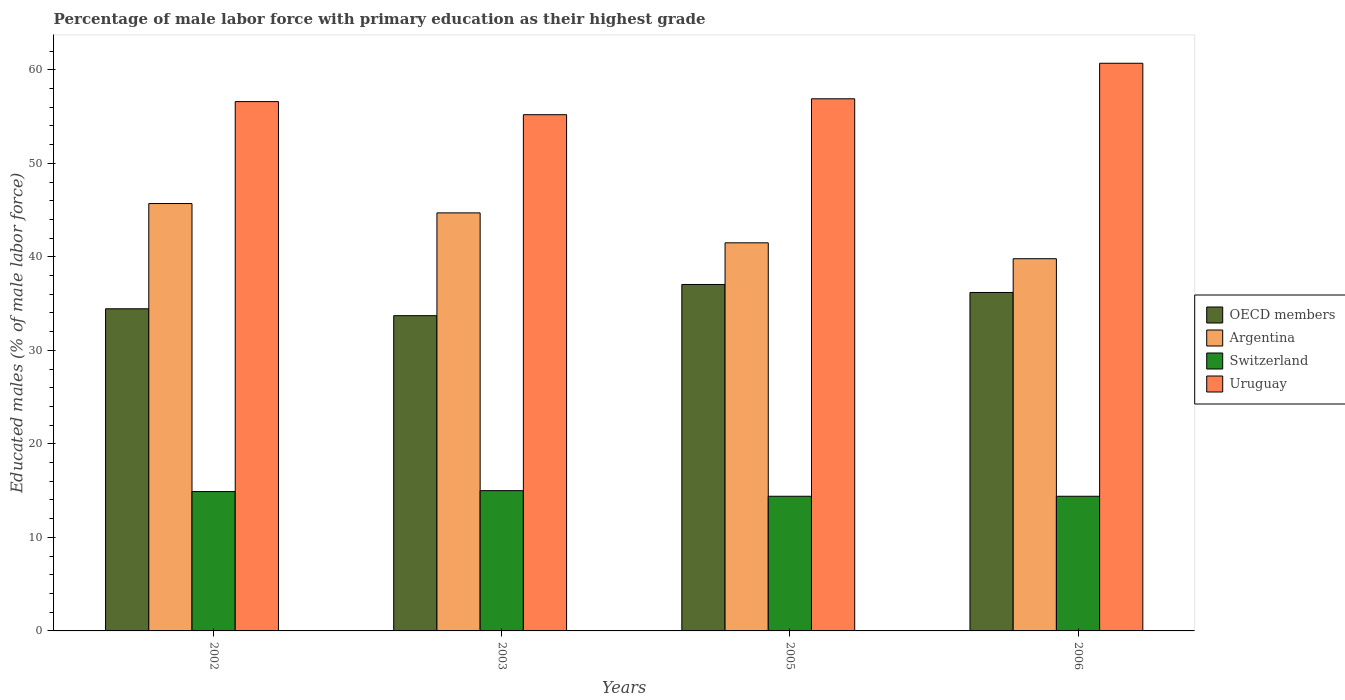How many different coloured bars are there?
Make the answer very short. 4. How many groups of bars are there?
Your answer should be very brief. 4. Are the number of bars on each tick of the X-axis equal?
Provide a short and direct response. Yes. How many bars are there on the 4th tick from the left?
Your answer should be compact. 4. What is the label of the 2nd group of bars from the left?
Provide a short and direct response. 2003. What is the percentage of male labor force with primary education in OECD members in 2003?
Your answer should be compact. 33.71. Across all years, what is the maximum percentage of male labor force with primary education in Switzerland?
Provide a succinct answer. 15. Across all years, what is the minimum percentage of male labor force with primary education in Uruguay?
Offer a very short reply. 55.2. In which year was the percentage of male labor force with primary education in Argentina minimum?
Keep it short and to the point. 2006. What is the total percentage of male labor force with primary education in OECD members in the graph?
Keep it short and to the point. 141.39. What is the difference between the percentage of male labor force with primary education in Uruguay in 2002 and that in 2006?
Offer a terse response. -4.1. What is the difference between the percentage of male labor force with primary education in Argentina in 2003 and the percentage of male labor force with primary education in OECD members in 2002?
Offer a terse response. 10.25. What is the average percentage of male labor force with primary education in Argentina per year?
Ensure brevity in your answer.  42.93. In the year 2003, what is the difference between the percentage of male labor force with primary education in Switzerland and percentage of male labor force with primary education in OECD members?
Ensure brevity in your answer.  -18.71. In how many years, is the percentage of male labor force with primary education in Switzerland greater than 38 %?
Make the answer very short. 0. What is the ratio of the percentage of male labor force with primary education in Argentina in 2002 to that in 2006?
Provide a succinct answer. 1.15. Is the percentage of male labor force with primary education in Switzerland in 2003 less than that in 2006?
Ensure brevity in your answer.  No. Is the difference between the percentage of male labor force with primary education in Switzerland in 2005 and 2006 greater than the difference between the percentage of male labor force with primary education in OECD members in 2005 and 2006?
Offer a very short reply. No. What is the difference between the highest and the second highest percentage of male labor force with primary education in OECD members?
Ensure brevity in your answer.  0.85. What is the difference between the highest and the lowest percentage of male labor force with primary education in Argentina?
Offer a very short reply. 5.9. Is the sum of the percentage of male labor force with primary education in OECD members in 2003 and 2005 greater than the maximum percentage of male labor force with primary education in Argentina across all years?
Provide a succinct answer. Yes. Is it the case that in every year, the sum of the percentage of male labor force with primary education in Uruguay and percentage of male labor force with primary education in Argentina is greater than the sum of percentage of male labor force with primary education in Switzerland and percentage of male labor force with primary education in OECD members?
Your answer should be compact. Yes. What does the 4th bar from the left in 2005 represents?
Your response must be concise. Uruguay. What does the 1st bar from the right in 2005 represents?
Ensure brevity in your answer.  Uruguay. How many bars are there?
Your answer should be compact. 16. Are all the bars in the graph horizontal?
Give a very brief answer. No. What is the difference between two consecutive major ticks on the Y-axis?
Make the answer very short. 10. Are the values on the major ticks of Y-axis written in scientific E-notation?
Make the answer very short. No. Does the graph contain grids?
Ensure brevity in your answer.  No. Where does the legend appear in the graph?
Give a very brief answer. Center right. What is the title of the graph?
Provide a short and direct response. Percentage of male labor force with primary education as their highest grade. Does "European Union" appear as one of the legend labels in the graph?
Your answer should be compact. No. What is the label or title of the X-axis?
Keep it short and to the point. Years. What is the label or title of the Y-axis?
Give a very brief answer. Educated males (% of male labor force). What is the Educated males (% of male labor force) in OECD members in 2002?
Ensure brevity in your answer.  34.45. What is the Educated males (% of male labor force) of Argentina in 2002?
Make the answer very short. 45.7. What is the Educated males (% of male labor force) in Switzerland in 2002?
Offer a terse response. 14.9. What is the Educated males (% of male labor force) of Uruguay in 2002?
Ensure brevity in your answer.  56.6. What is the Educated males (% of male labor force) in OECD members in 2003?
Offer a very short reply. 33.71. What is the Educated males (% of male labor force) in Argentina in 2003?
Provide a succinct answer. 44.7. What is the Educated males (% of male labor force) of Uruguay in 2003?
Provide a short and direct response. 55.2. What is the Educated males (% of male labor force) of OECD members in 2005?
Give a very brief answer. 37.04. What is the Educated males (% of male labor force) in Argentina in 2005?
Provide a short and direct response. 41.5. What is the Educated males (% of male labor force) of Switzerland in 2005?
Give a very brief answer. 14.4. What is the Educated males (% of male labor force) of Uruguay in 2005?
Make the answer very short. 56.9. What is the Educated males (% of male labor force) of OECD members in 2006?
Offer a terse response. 36.19. What is the Educated males (% of male labor force) of Argentina in 2006?
Give a very brief answer. 39.8. What is the Educated males (% of male labor force) of Switzerland in 2006?
Give a very brief answer. 14.4. What is the Educated males (% of male labor force) in Uruguay in 2006?
Keep it short and to the point. 60.7. Across all years, what is the maximum Educated males (% of male labor force) of OECD members?
Ensure brevity in your answer.  37.04. Across all years, what is the maximum Educated males (% of male labor force) of Argentina?
Provide a short and direct response. 45.7. Across all years, what is the maximum Educated males (% of male labor force) in Uruguay?
Your response must be concise. 60.7. Across all years, what is the minimum Educated males (% of male labor force) in OECD members?
Your answer should be compact. 33.71. Across all years, what is the minimum Educated males (% of male labor force) of Argentina?
Make the answer very short. 39.8. Across all years, what is the minimum Educated males (% of male labor force) in Switzerland?
Give a very brief answer. 14.4. Across all years, what is the minimum Educated males (% of male labor force) of Uruguay?
Provide a short and direct response. 55.2. What is the total Educated males (% of male labor force) of OECD members in the graph?
Keep it short and to the point. 141.39. What is the total Educated males (% of male labor force) of Argentina in the graph?
Keep it short and to the point. 171.7. What is the total Educated males (% of male labor force) in Switzerland in the graph?
Give a very brief answer. 58.7. What is the total Educated males (% of male labor force) in Uruguay in the graph?
Your answer should be very brief. 229.4. What is the difference between the Educated males (% of male labor force) of OECD members in 2002 and that in 2003?
Make the answer very short. 0.74. What is the difference between the Educated males (% of male labor force) in Uruguay in 2002 and that in 2003?
Provide a succinct answer. 1.4. What is the difference between the Educated males (% of male labor force) of OECD members in 2002 and that in 2005?
Keep it short and to the point. -2.6. What is the difference between the Educated males (% of male labor force) in Switzerland in 2002 and that in 2005?
Keep it short and to the point. 0.5. What is the difference between the Educated males (% of male labor force) in OECD members in 2002 and that in 2006?
Your answer should be compact. -1.74. What is the difference between the Educated males (% of male labor force) in Argentina in 2002 and that in 2006?
Offer a terse response. 5.9. What is the difference between the Educated males (% of male labor force) in Switzerland in 2002 and that in 2006?
Keep it short and to the point. 0.5. What is the difference between the Educated males (% of male labor force) of Uruguay in 2002 and that in 2006?
Ensure brevity in your answer.  -4.1. What is the difference between the Educated males (% of male labor force) in OECD members in 2003 and that in 2005?
Provide a succinct answer. -3.34. What is the difference between the Educated males (% of male labor force) in Argentina in 2003 and that in 2005?
Give a very brief answer. 3.2. What is the difference between the Educated males (% of male labor force) of Switzerland in 2003 and that in 2005?
Ensure brevity in your answer.  0.6. What is the difference between the Educated males (% of male labor force) of Uruguay in 2003 and that in 2005?
Offer a very short reply. -1.7. What is the difference between the Educated males (% of male labor force) of OECD members in 2003 and that in 2006?
Keep it short and to the point. -2.48. What is the difference between the Educated males (% of male labor force) of Argentina in 2003 and that in 2006?
Ensure brevity in your answer.  4.9. What is the difference between the Educated males (% of male labor force) in Switzerland in 2003 and that in 2006?
Make the answer very short. 0.6. What is the difference between the Educated males (% of male labor force) of OECD members in 2005 and that in 2006?
Your answer should be compact. 0.85. What is the difference between the Educated males (% of male labor force) of OECD members in 2002 and the Educated males (% of male labor force) of Argentina in 2003?
Your answer should be very brief. -10.25. What is the difference between the Educated males (% of male labor force) of OECD members in 2002 and the Educated males (% of male labor force) of Switzerland in 2003?
Give a very brief answer. 19.45. What is the difference between the Educated males (% of male labor force) of OECD members in 2002 and the Educated males (% of male labor force) of Uruguay in 2003?
Ensure brevity in your answer.  -20.75. What is the difference between the Educated males (% of male labor force) in Argentina in 2002 and the Educated males (% of male labor force) in Switzerland in 2003?
Give a very brief answer. 30.7. What is the difference between the Educated males (% of male labor force) of Switzerland in 2002 and the Educated males (% of male labor force) of Uruguay in 2003?
Your answer should be very brief. -40.3. What is the difference between the Educated males (% of male labor force) of OECD members in 2002 and the Educated males (% of male labor force) of Argentina in 2005?
Your answer should be compact. -7.05. What is the difference between the Educated males (% of male labor force) in OECD members in 2002 and the Educated males (% of male labor force) in Switzerland in 2005?
Provide a succinct answer. 20.05. What is the difference between the Educated males (% of male labor force) of OECD members in 2002 and the Educated males (% of male labor force) of Uruguay in 2005?
Your response must be concise. -22.45. What is the difference between the Educated males (% of male labor force) in Argentina in 2002 and the Educated males (% of male labor force) in Switzerland in 2005?
Your answer should be compact. 31.3. What is the difference between the Educated males (% of male labor force) in Switzerland in 2002 and the Educated males (% of male labor force) in Uruguay in 2005?
Your response must be concise. -42. What is the difference between the Educated males (% of male labor force) of OECD members in 2002 and the Educated males (% of male labor force) of Argentina in 2006?
Ensure brevity in your answer.  -5.35. What is the difference between the Educated males (% of male labor force) in OECD members in 2002 and the Educated males (% of male labor force) in Switzerland in 2006?
Give a very brief answer. 20.05. What is the difference between the Educated males (% of male labor force) of OECD members in 2002 and the Educated males (% of male labor force) of Uruguay in 2006?
Provide a succinct answer. -26.25. What is the difference between the Educated males (% of male labor force) of Argentina in 2002 and the Educated males (% of male labor force) of Switzerland in 2006?
Offer a very short reply. 31.3. What is the difference between the Educated males (% of male labor force) of Switzerland in 2002 and the Educated males (% of male labor force) of Uruguay in 2006?
Provide a succinct answer. -45.8. What is the difference between the Educated males (% of male labor force) of OECD members in 2003 and the Educated males (% of male labor force) of Argentina in 2005?
Make the answer very short. -7.79. What is the difference between the Educated males (% of male labor force) of OECD members in 2003 and the Educated males (% of male labor force) of Switzerland in 2005?
Provide a succinct answer. 19.31. What is the difference between the Educated males (% of male labor force) of OECD members in 2003 and the Educated males (% of male labor force) of Uruguay in 2005?
Your response must be concise. -23.19. What is the difference between the Educated males (% of male labor force) in Argentina in 2003 and the Educated males (% of male labor force) in Switzerland in 2005?
Offer a very short reply. 30.3. What is the difference between the Educated males (% of male labor force) of Argentina in 2003 and the Educated males (% of male labor force) of Uruguay in 2005?
Your answer should be compact. -12.2. What is the difference between the Educated males (% of male labor force) of Switzerland in 2003 and the Educated males (% of male labor force) of Uruguay in 2005?
Your answer should be compact. -41.9. What is the difference between the Educated males (% of male labor force) of OECD members in 2003 and the Educated males (% of male labor force) of Argentina in 2006?
Provide a succinct answer. -6.09. What is the difference between the Educated males (% of male labor force) in OECD members in 2003 and the Educated males (% of male labor force) in Switzerland in 2006?
Your response must be concise. 19.31. What is the difference between the Educated males (% of male labor force) in OECD members in 2003 and the Educated males (% of male labor force) in Uruguay in 2006?
Offer a terse response. -26.99. What is the difference between the Educated males (% of male labor force) in Argentina in 2003 and the Educated males (% of male labor force) in Switzerland in 2006?
Your response must be concise. 30.3. What is the difference between the Educated males (% of male labor force) of Switzerland in 2003 and the Educated males (% of male labor force) of Uruguay in 2006?
Keep it short and to the point. -45.7. What is the difference between the Educated males (% of male labor force) in OECD members in 2005 and the Educated males (% of male labor force) in Argentina in 2006?
Your answer should be very brief. -2.76. What is the difference between the Educated males (% of male labor force) in OECD members in 2005 and the Educated males (% of male labor force) in Switzerland in 2006?
Give a very brief answer. 22.64. What is the difference between the Educated males (% of male labor force) in OECD members in 2005 and the Educated males (% of male labor force) in Uruguay in 2006?
Provide a succinct answer. -23.66. What is the difference between the Educated males (% of male labor force) in Argentina in 2005 and the Educated males (% of male labor force) in Switzerland in 2006?
Offer a terse response. 27.1. What is the difference between the Educated males (% of male labor force) in Argentina in 2005 and the Educated males (% of male labor force) in Uruguay in 2006?
Keep it short and to the point. -19.2. What is the difference between the Educated males (% of male labor force) of Switzerland in 2005 and the Educated males (% of male labor force) of Uruguay in 2006?
Provide a succinct answer. -46.3. What is the average Educated males (% of male labor force) of OECD members per year?
Ensure brevity in your answer.  35.35. What is the average Educated males (% of male labor force) in Argentina per year?
Your answer should be compact. 42.92. What is the average Educated males (% of male labor force) in Switzerland per year?
Your response must be concise. 14.68. What is the average Educated males (% of male labor force) in Uruguay per year?
Provide a succinct answer. 57.35. In the year 2002, what is the difference between the Educated males (% of male labor force) in OECD members and Educated males (% of male labor force) in Argentina?
Keep it short and to the point. -11.25. In the year 2002, what is the difference between the Educated males (% of male labor force) of OECD members and Educated males (% of male labor force) of Switzerland?
Offer a very short reply. 19.55. In the year 2002, what is the difference between the Educated males (% of male labor force) in OECD members and Educated males (% of male labor force) in Uruguay?
Your answer should be compact. -22.15. In the year 2002, what is the difference between the Educated males (% of male labor force) of Argentina and Educated males (% of male labor force) of Switzerland?
Make the answer very short. 30.8. In the year 2002, what is the difference between the Educated males (% of male labor force) of Argentina and Educated males (% of male labor force) of Uruguay?
Your response must be concise. -10.9. In the year 2002, what is the difference between the Educated males (% of male labor force) of Switzerland and Educated males (% of male labor force) of Uruguay?
Your response must be concise. -41.7. In the year 2003, what is the difference between the Educated males (% of male labor force) of OECD members and Educated males (% of male labor force) of Argentina?
Make the answer very short. -10.99. In the year 2003, what is the difference between the Educated males (% of male labor force) of OECD members and Educated males (% of male labor force) of Switzerland?
Ensure brevity in your answer.  18.71. In the year 2003, what is the difference between the Educated males (% of male labor force) of OECD members and Educated males (% of male labor force) of Uruguay?
Ensure brevity in your answer.  -21.49. In the year 2003, what is the difference between the Educated males (% of male labor force) of Argentina and Educated males (% of male labor force) of Switzerland?
Give a very brief answer. 29.7. In the year 2003, what is the difference between the Educated males (% of male labor force) of Argentina and Educated males (% of male labor force) of Uruguay?
Provide a short and direct response. -10.5. In the year 2003, what is the difference between the Educated males (% of male labor force) of Switzerland and Educated males (% of male labor force) of Uruguay?
Provide a succinct answer. -40.2. In the year 2005, what is the difference between the Educated males (% of male labor force) of OECD members and Educated males (% of male labor force) of Argentina?
Give a very brief answer. -4.46. In the year 2005, what is the difference between the Educated males (% of male labor force) of OECD members and Educated males (% of male labor force) of Switzerland?
Keep it short and to the point. 22.64. In the year 2005, what is the difference between the Educated males (% of male labor force) in OECD members and Educated males (% of male labor force) in Uruguay?
Offer a terse response. -19.86. In the year 2005, what is the difference between the Educated males (% of male labor force) in Argentina and Educated males (% of male labor force) in Switzerland?
Offer a terse response. 27.1. In the year 2005, what is the difference between the Educated males (% of male labor force) of Argentina and Educated males (% of male labor force) of Uruguay?
Make the answer very short. -15.4. In the year 2005, what is the difference between the Educated males (% of male labor force) in Switzerland and Educated males (% of male labor force) in Uruguay?
Your response must be concise. -42.5. In the year 2006, what is the difference between the Educated males (% of male labor force) of OECD members and Educated males (% of male labor force) of Argentina?
Provide a short and direct response. -3.61. In the year 2006, what is the difference between the Educated males (% of male labor force) of OECD members and Educated males (% of male labor force) of Switzerland?
Ensure brevity in your answer.  21.79. In the year 2006, what is the difference between the Educated males (% of male labor force) in OECD members and Educated males (% of male labor force) in Uruguay?
Provide a succinct answer. -24.51. In the year 2006, what is the difference between the Educated males (% of male labor force) of Argentina and Educated males (% of male labor force) of Switzerland?
Provide a short and direct response. 25.4. In the year 2006, what is the difference between the Educated males (% of male labor force) of Argentina and Educated males (% of male labor force) of Uruguay?
Your answer should be compact. -20.9. In the year 2006, what is the difference between the Educated males (% of male labor force) in Switzerland and Educated males (% of male labor force) in Uruguay?
Provide a succinct answer. -46.3. What is the ratio of the Educated males (% of male labor force) of OECD members in 2002 to that in 2003?
Give a very brief answer. 1.02. What is the ratio of the Educated males (% of male labor force) of Argentina in 2002 to that in 2003?
Keep it short and to the point. 1.02. What is the ratio of the Educated males (% of male labor force) in Switzerland in 2002 to that in 2003?
Provide a succinct answer. 0.99. What is the ratio of the Educated males (% of male labor force) in Uruguay in 2002 to that in 2003?
Your response must be concise. 1.03. What is the ratio of the Educated males (% of male labor force) in OECD members in 2002 to that in 2005?
Your answer should be very brief. 0.93. What is the ratio of the Educated males (% of male labor force) in Argentina in 2002 to that in 2005?
Your response must be concise. 1.1. What is the ratio of the Educated males (% of male labor force) of Switzerland in 2002 to that in 2005?
Your answer should be compact. 1.03. What is the ratio of the Educated males (% of male labor force) in OECD members in 2002 to that in 2006?
Ensure brevity in your answer.  0.95. What is the ratio of the Educated males (% of male labor force) in Argentina in 2002 to that in 2006?
Offer a terse response. 1.15. What is the ratio of the Educated males (% of male labor force) of Switzerland in 2002 to that in 2006?
Your answer should be very brief. 1.03. What is the ratio of the Educated males (% of male labor force) of Uruguay in 2002 to that in 2006?
Offer a very short reply. 0.93. What is the ratio of the Educated males (% of male labor force) of OECD members in 2003 to that in 2005?
Provide a succinct answer. 0.91. What is the ratio of the Educated males (% of male labor force) in Argentina in 2003 to that in 2005?
Give a very brief answer. 1.08. What is the ratio of the Educated males (% of male labor force) of Switzerland in 2003 to that in 2005?
Give a very brief answer. 1.04. What is the ratio of the Educated males (% of male labor force) in Uruguay in 2003 to that in 2005?
Make the answer very short. 0.97. What is the ratio of the Educated males (% of male labor force) of OECD members in 2003 to that in 2006?
Provide a short and direct response. 0.93. What is the ratio of the Educated males (% of male labor force) in Argentina in 2003 to that in 2006?
Give a very brief answer. 1.12. What is the ratio of the Educated males (% of male labor force) of Switzerland in 2003 to that in 2006?
Offer a terse response. 1.04. What is the ratio of the Educated males (% of male labor force) in Uruguay in 2003 to that in 2006?
Offer a very short reply. 0.91. What is the ratio of the Educated males (% of male labor force) in OECD members in 2005 to that in 2006?
Ensure brevity in your answer.  1.02. What is the ratio of the Educated males (% of male labor force) in Argentina in 2005 to that in 2006?
Provide a short and direct response. 1.04. What is the ratio of the Educated males (% of male labor force) of Uruguay in 2005 to that in 2006?
Provide a short and direct response. 0.94. What is the difference between the highest and the second highest Educated males (% of male labor force) of OECD members?
Offer a very short reply. 0.85. What is the difference between the highest and the second highest Educated males (% of male labor force) in Switzerland?
Provide a succinct answer. 0.1. What is the difference between the highest and the lowest Educated males (% of male labor force) in OECD members?
Your response must be concise. 3.34. What is the difference between the highest and the lowest Educated males (% of male labor force) of Uruguay?
Ensure brevity in your answer.  5.5. 